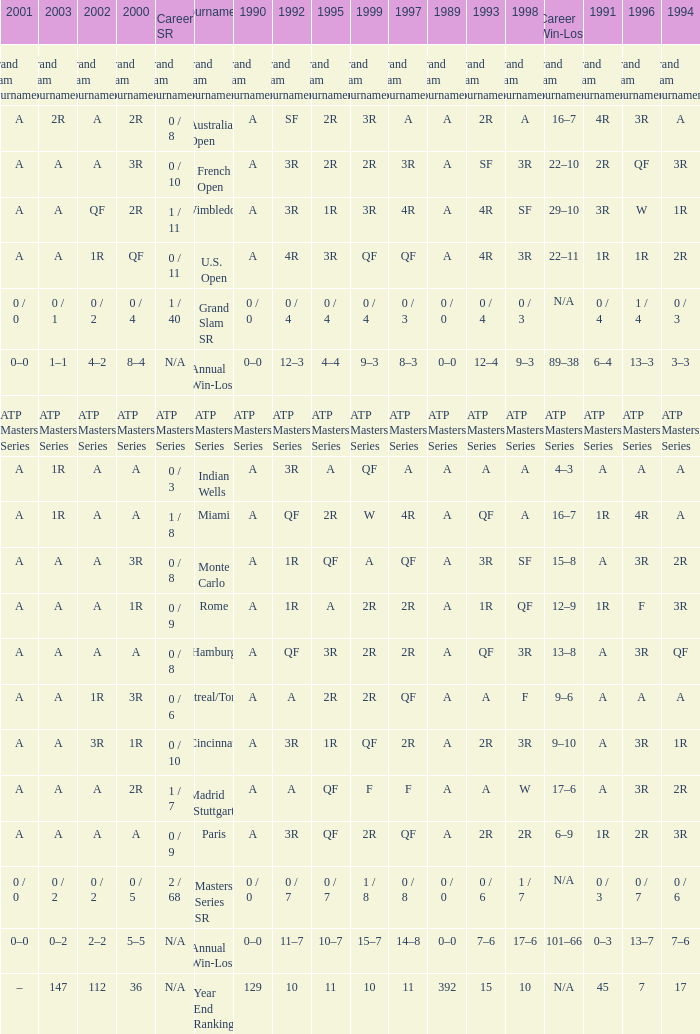Could you parse the entire table as a dict? {'header': ['2001', '2003', '2002', '2000', 'Career SR', 'Tournament', '1990', '1992', '1995', '1999', '1997', '1989', '1993', '1998', 'Career Win-Loss', '1991', '1996', '1994'], 'rows': [['Grand Slam Tournaments', 'Grand Slam Tournaments', 'Grand Slam Tournaments', 'Grand Slam Tournaments', 'Grand Slam Tournaments', 'Grand Slam Tournaments', 'Grand Slam Tournaments', 'Grand Slam Tournaments', 'Grand Slam Tournaments', 'Grand Slam Tournaments', 'Grand Slam Tournaments', 'Grand Slam Tournaments', 'Grand Slam Tournaments', 'Grand Slam Tournaments', 'Grand Slam Tournaments', 'Grand Slam Tournaments', 'Grand Slam Tournaments', 'Grand Slam Tournaments'], ['A', '2R', 'A', '2R', '0 / 8', 'Australian Open', 'A', 'SF', '2R', '3R', 'A', 'A', '2R', 'A', '16–7', '4R', '3R', 'A'], ['A', 'A', 'A', '3R', '0 / 10', 'French Open', 'A', '3R', '2R', '2R', '3R', 'A', 'SF', '3R', '22–10', '2R', 'QF', '3R'], ['A', 'A', 'QF', '2R', '1 / 11', 'Wimbledon', 'A', '3R', '1R', '3R', '4R', 'A', '4R', 'SF', '29–10', '3R', 'W', '1R'], ['A', 'A', '1R', 'QF', '0 / 11', 'U.S. Open', 'A', '4R', '3R', 'QF', 'QF', 'A', '4R', '3R', '22–11', '1R', '1R', '2R'], ['0 / 0', '0 / 1', '0 / 2', '0 / 4', '1 / 40', 'Grand Slam SR', '0 / 0', '0 / 4', '0 / 4', '0 / 4', '0 / 3', '0 / 0', '0 / 4', '0 / 3', 'N/A', '0 / 4', '1 / 4', '0 / 3'], ['0–0', '1–1', '4–2', '8–4', 'N/A', 'Annual Win-Loss', '0–0', '12–3', '4–4', '9–3', '8–3', '0–0', '12–4', '9–3', '89–38', '6–4', '13–3', '3–3'], ['ATP Masters Series', 'ATP Masters Series', 'ATP Masters Series', 'ATP Masters Series', 'ATP Masters Series', 'ATP Masters Series', 'ATP Masters Series', 'ATP Masters Series', 'ATP Masters Series', 'ATP Masters Series', 'ATP Masters Series', 'ATP Masters Series', 'ATP Masters Series', 'ATP Masters Series', 'ATP Masters Series', 'ATP Masters Series', 'ATP Masters Series', 'ATP Masters Series'], ['A', '1R', 'A', 'A', '0 / 3', 'Indian Wells', 'A', '3R', 'A', 'QF', 'A', 'A', 'A', 'A', '4–3', 'A', 'A', 'A'], ['A', '1R', 'A', 'A', '1 / 8', 'Miami', 'A', 'QF', '2R', 'W', '4R', 'A', 'QF', 'A', '16–7', '1R', '4R', 'A'], ['A', 'A', 'A', '3R', '0 / 8', 'Monte Carlo', 'A', '1R', 'QF', 'A', 'QF', 'A', '3R', 'SF', '15–8', 'A', '3R', '2R'], ['A', 'A', 'A', '1R', '0 / 9', 'Rome', 'A', '1R', 'A', '2R', '2R', 'A', '1R', 'QF', '12–9', '1R', 'F', '3R'], ['A', 'A', 'A', 'A', '0 / 8', 'Hamburg', 'A', 'QF', '3R', '2R', '2R', 'A', 'QF', '3R', '13–8', 'A', '3R', 'QF'], ['A', 'A', '1R', '3R', '0 / 6', 'Montreal/Toronto', 'A', 'A', '2R', '2R', 'QF', 'A', 'A', 'F', '9–6', 'A', 'A', 'A'], ['A', 'A', '3R', '1R', '0 / 10', 'Cincinnati', 'A', '3R', '1R', 'QF', '2R', 'A', '2R', '3R', '9–10', 'A', '3R', '1R'], ['A', 'A', 'A', '2R', '1 / 7', 'Madrid (Stuttgart)', 'A', 'A', 'QF', 'F', 'F', 'A', 'A', 'W', '17–6', 'A', '3R', '2R'], ['A', 'A', 'A', 'A', '0 / 9', 'Paris', 'A', '3R', 'QF', '2R', 'QF', 'A', '2R', '2R', '6–9', '1R', '2R', '3R'], ['0 / 0', '0 / 2', '0 / 2', '0 / 5', '2 / 68', 'Masters Series SR', '0 / 0', '0 / 7', '0 / 7', '1 / 8', '0 / 8', '0 / 0', '0 / 6', '1 / 7', 'N/A', '0 / 3', '0 / 7', '0 / 6'], ['0–0', '0–2', '2–2', '5–5', 'N/A', 'Annual Win-Loss', '0–0', '11–7', '10–7', '15–7', '14–8', '0–0', '7–6', '17–6', '101–66', '0–3', '13–7', '7–6'], ['–', '147', '112', '36', 'N/A', 'Year End Ranking', '129', '10', '11', '10', '11', '392', '15', '10', 'N/A', '45', '7', '17']]} What was the value in 1989 with QF in 1997 and A in 1993? A. 